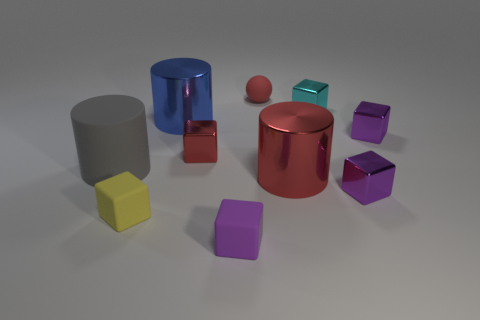Subtract all red spheres. How many purple cubes are left? 3 Subtract all small yellow rubber cubes. How many cubes are left? 5 Subtract all cyan blocks. How many blocks are left? 5 Subtract all brown blocks. Subtract all red cylinders. How many blocks are left? 6 Subtract all blocks. How many objects are left? 4 Add 9 big red objects. How many big red objects exist? 10 Subtract 0 purple cylinders. How many objects are left? 10 Subtract all small cyan shiny objects. Subtract all cyan metallic cubes. How many objects are left? 8 Add 1 large blue things. How many large blue things are left? 2 